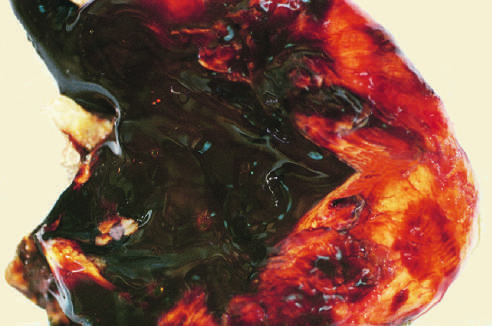how does sectioning of ovary show a large endometriotic cyst?
Answer the question using a single word or phrase. With degenerated blood 